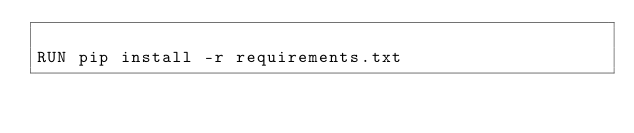<code> <loc_0><loc_0><loc_500><loc_500><_Dockerfile_>
RUN pip install -r requirements.txt
</code> 